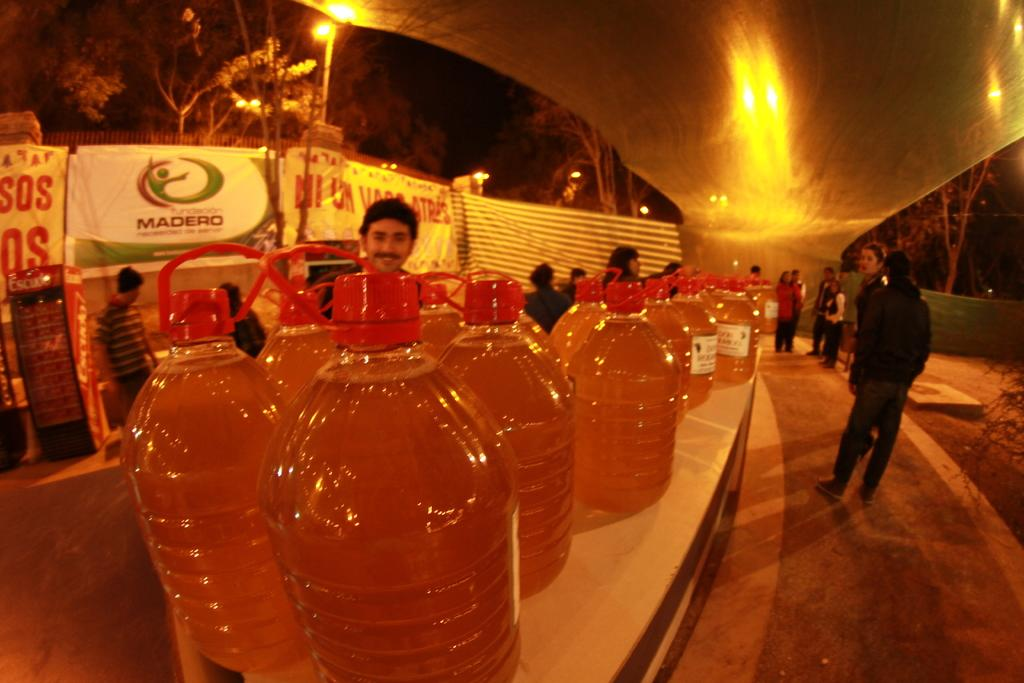<image>
Create a compact narrative representing the image presented. Table full of liquid containers with a "MADERO" ad in the background. 